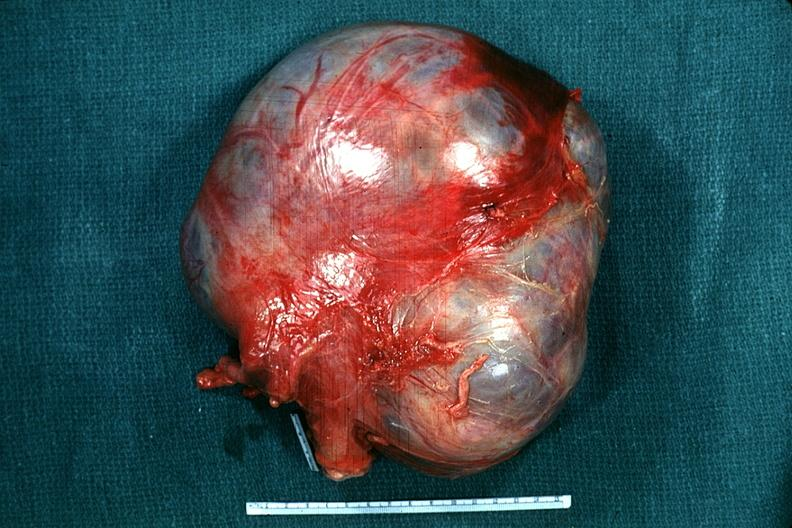s foot present?
Answer the question using a single word or phrase. No 